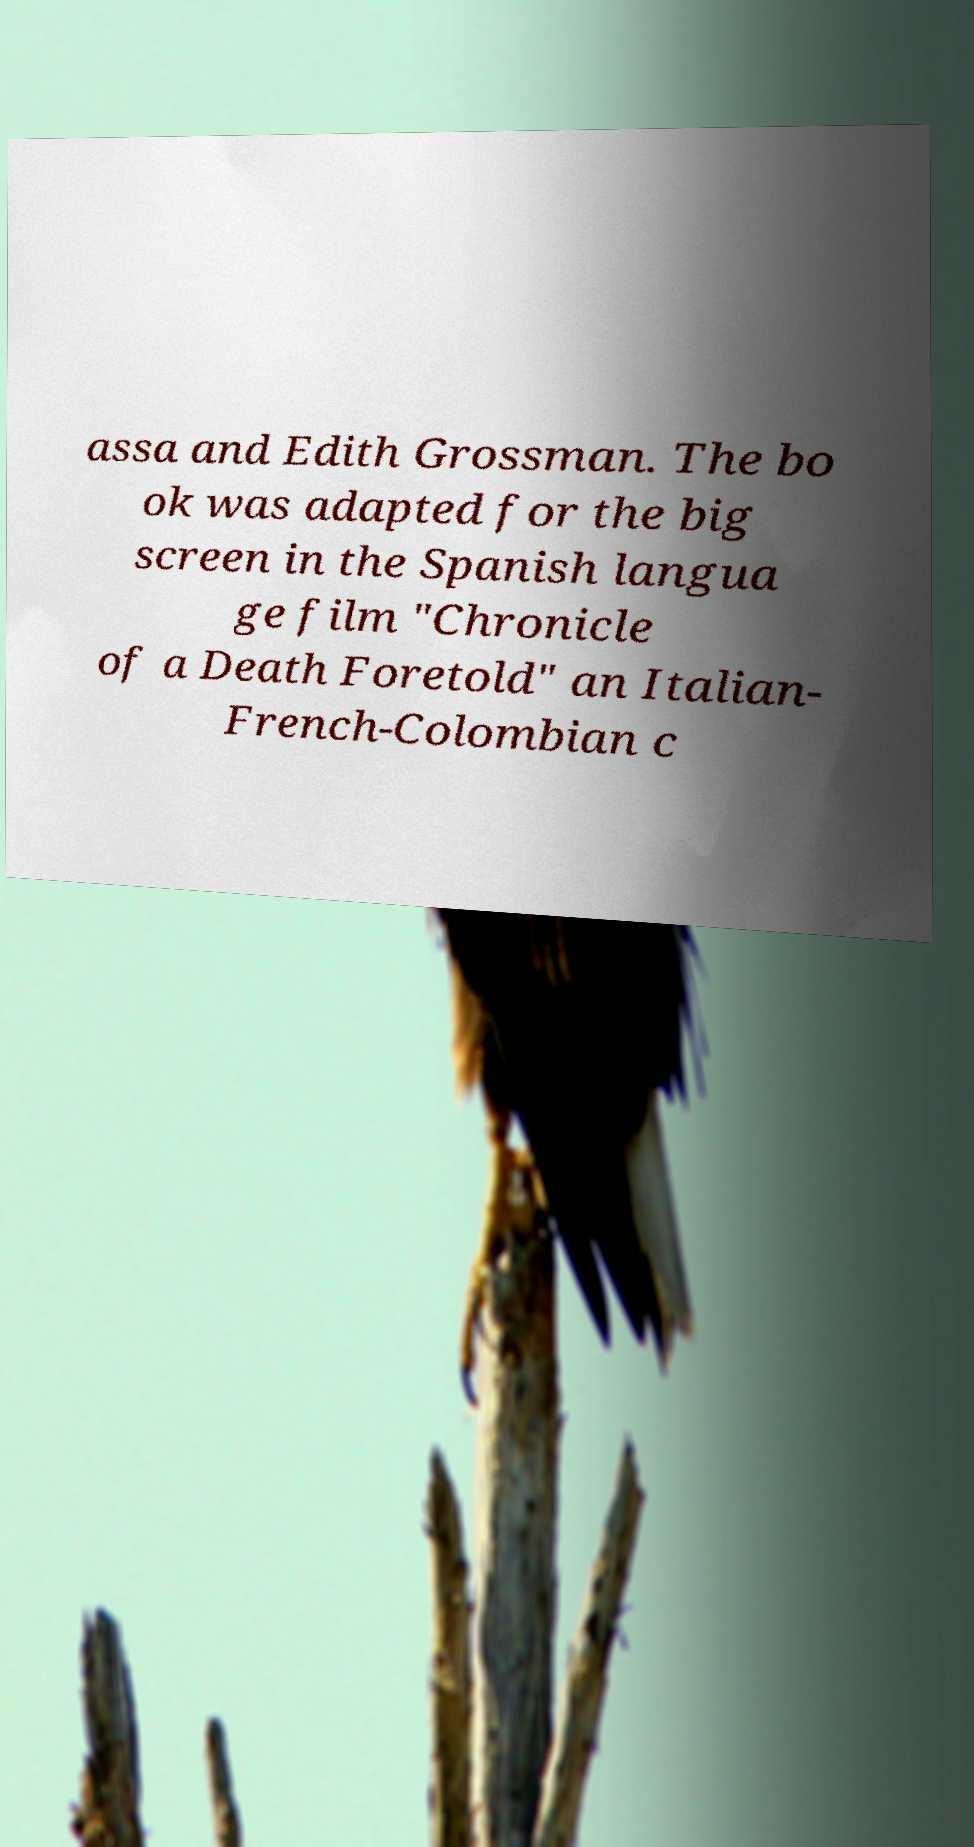What messages or text are displayed in this image? I need them in a readable, typed format. assa and Edith Grossman. The bo ok was adapted for the big screen in the Spanish langua ge film "Chronicle of a Death Foretold" an Italian- French-Colombian c 